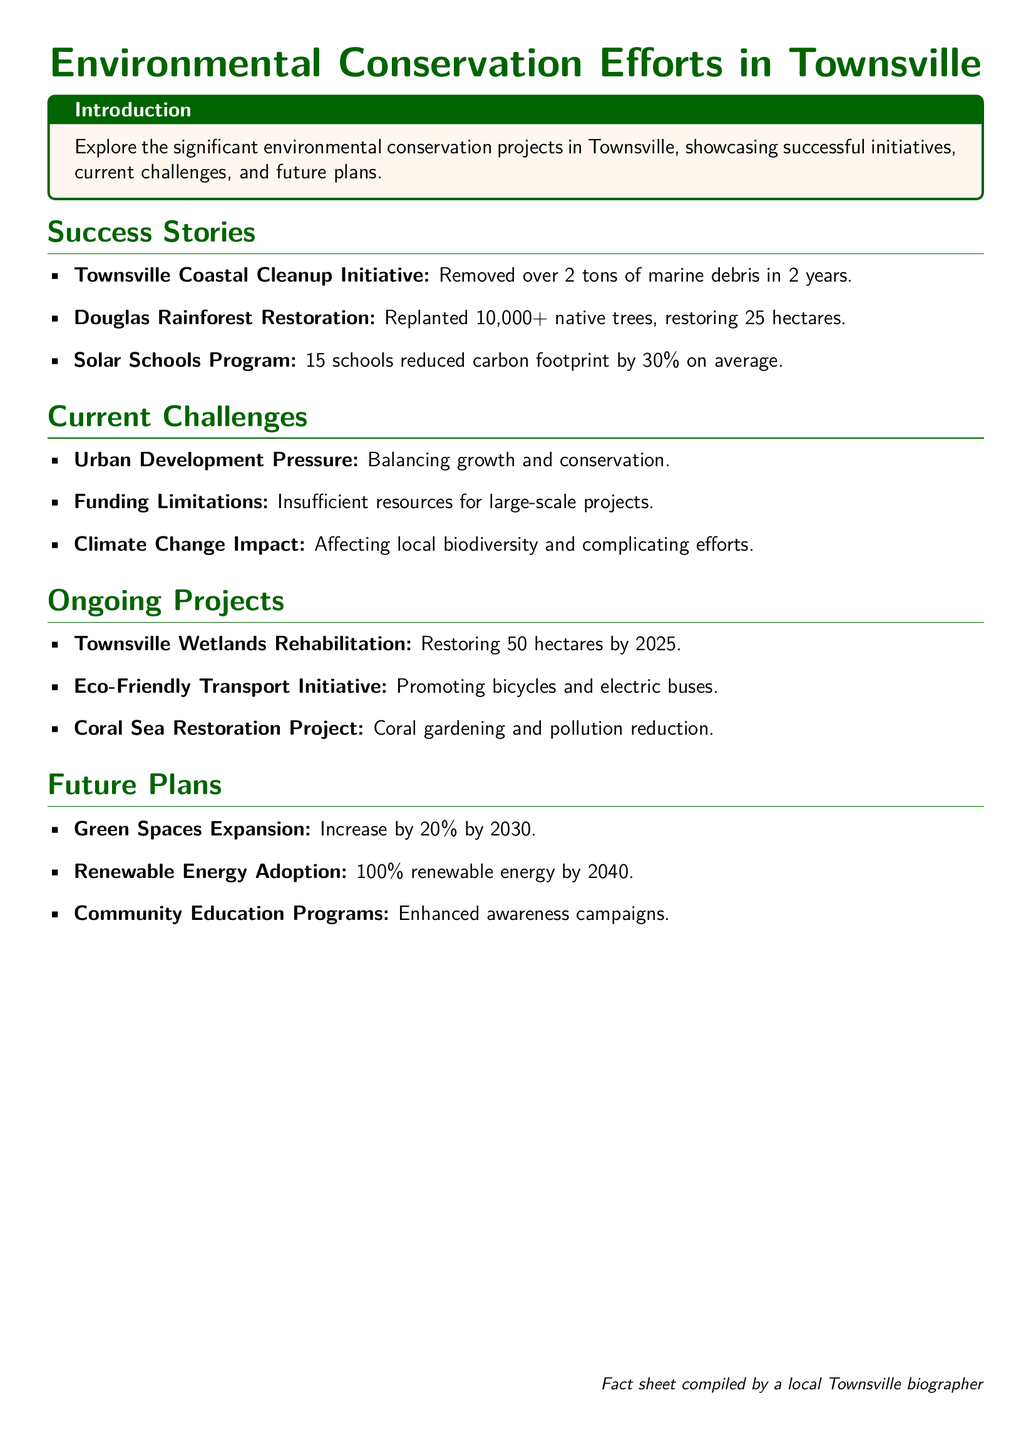What is the impact of the Townsville Coastal Cleanup Initiative? The initiative removed over 2 tons of marine debris in 2 years.
Answer: over 2 tons How many native trees were replanted in the Douglas Rainforest Restoration? The project replanted 10,000+ native trees.
Answer: 10,000+ What is a current challenge regarding urban development? The challenge involves balancing growth and conservation.
Answer: growth and conservation What is the goal for the Townsville Wetlands Rehabilitation project? The goal is to restore 50 hectares by 2025.
Answer: 50 hectares By what percentage have the schools in the Solar Schools Program reduced their carbon footprint? Schools reduced carbon footprint by 30% on average.
Answer: 30% What is the future plan for green spaces by 2030? The future plan is to increase green spaces by 20% by 2030.
Answer: 20% What community initiative is being promoted under the Eco-Friendly Transport Initiative? The initiative promotes bicycles and electric buses.
Answer: bicycles and electric buses What is the timeframe for achieving 100% renewable energy adoption? The goal is to achieve this by 2040.
Answer: 2040 